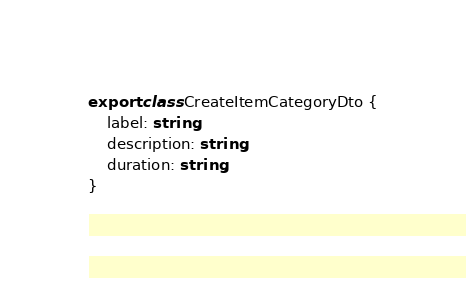<code> <loc_0><loc_0><loc_500><loc_500><_TypeScript_>export class CreateItemCategoryDto {
    label: string;
    description: string;
    duration: string;
}
</code> 